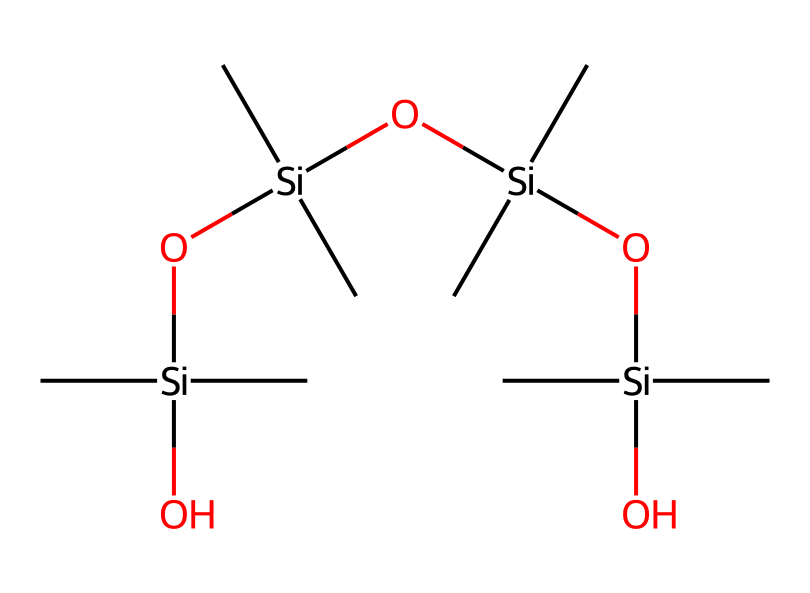What is the main functional group present in this chemical? The main functional group in this chemical is the silanol group, represented by the Si-OH part of the structure. There are multiple silanol groups in this compound.
Answer: silanol How many silicon atoms are present in the chemical? By analyzing the structure represented in the SMILES, we note that there are four silicon atoms (each represented by [Si]).
Answer: four What kind of polymer does this chemical represent? This chemical represents a siloxane polymer due to the alternating silicon and oxygen atoms in the backbone structure.
Answer: siloxane What is the total number of oxygen atoms in this chemical? In the chemical's structure, we can count three oxygen atoms associated with the silicon atoms in addition to the hydroxyl oxygen, bringing the total to four.
Answer: four How does the presence of silicon impact the thermal stability of this polymer? Silicon atoms enhance thermal stability by forming strong Si-O bonds, which are more resilient than C-C bonds found in organic polymers, leading to improved heat resistance.
Answer: improved heat resistance What is the significance of using organosilicon compounds in food packaging materials? Organosilicon compounds provide enhanced barrier properties and flexibility, while also being less toxic compared to traditional plastics, making them ideal for environmentally-friendly applications.
Answer: environmentally-friendly 